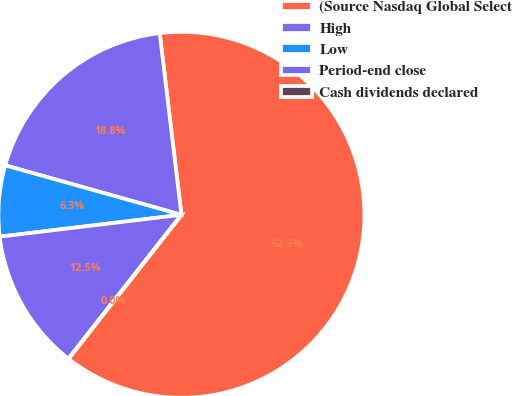Convert chart. <chart><loc_0><loc_0><loc_500><loc_500><pie_chart><fcel>(Source Nasdaq Global Select<fcel>High<fcel>Low<fcel>Period-end close<fcel>Cash dividends declared<nl><fcel>62.48%<fcel>18.75%<fcel>6.26%<fcel>12.5%<fcel>0.01%<nl></chart> 